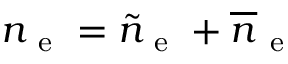Convert formula to latex. <formula><loc_0><loc_0><loc_500><loc_500>n _ { e } = \tilde { n } _ { e } + \overline { n } _ { e }</formula> 